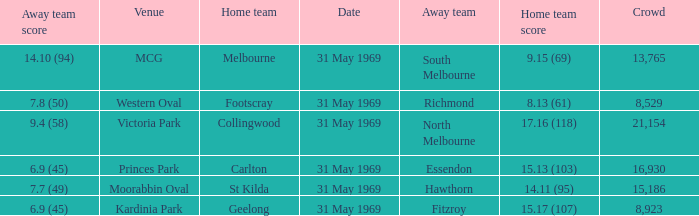What was the highest crowd in Victoria Park? 21154.0. 